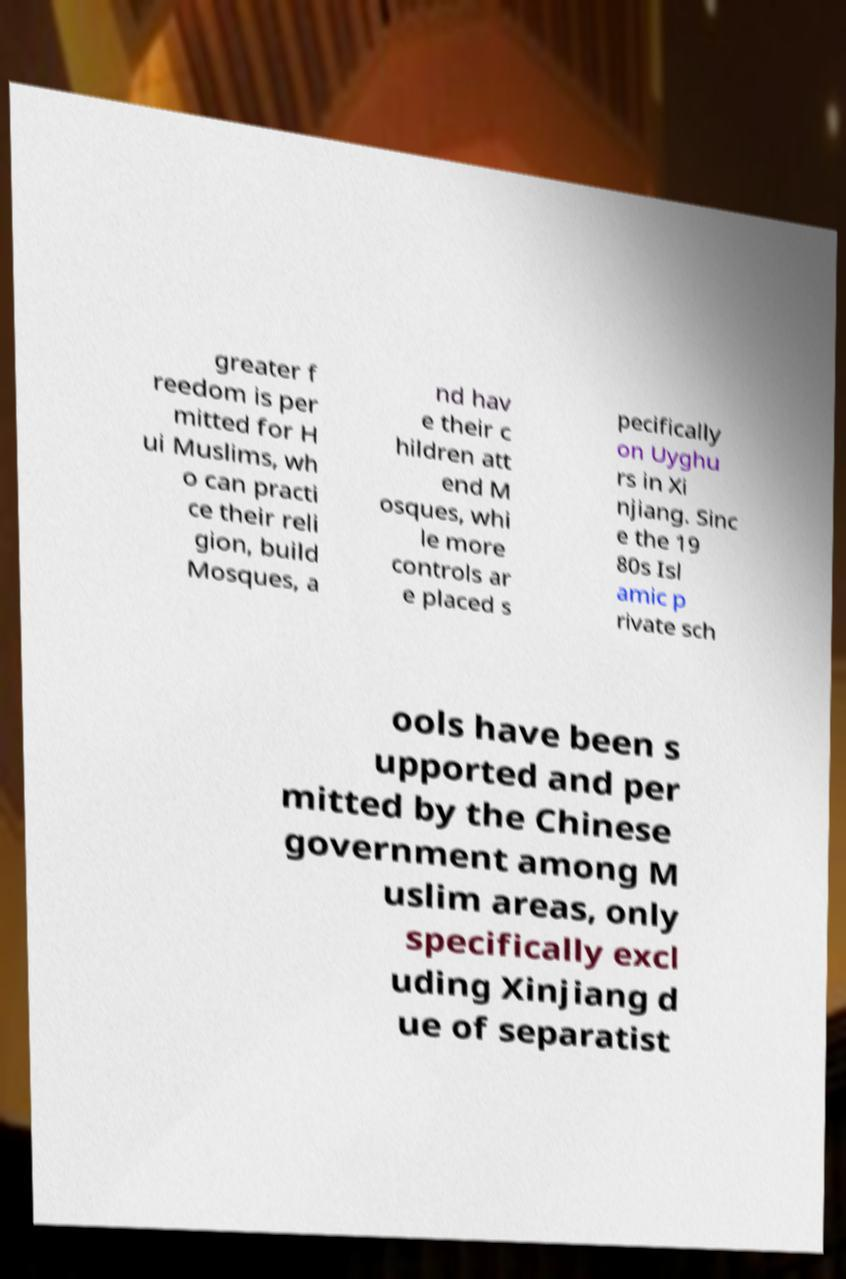Could you extract and type out the text from this image? greater f reedom is per mitted for H ui Muslims, wh o can practi ce their reli gion, build Mosques, a nd hav e their c hildren att end M osques, whi le more controls ar e placed s pecifically on Uyghu rs in Xi njiang. Sinc e the 19 80s Isl amic p rivate sch ools have been s upported and per mitted by the Chinese government among M uslim areas, only specifically excl uding Xinjiang d ue of separatist 